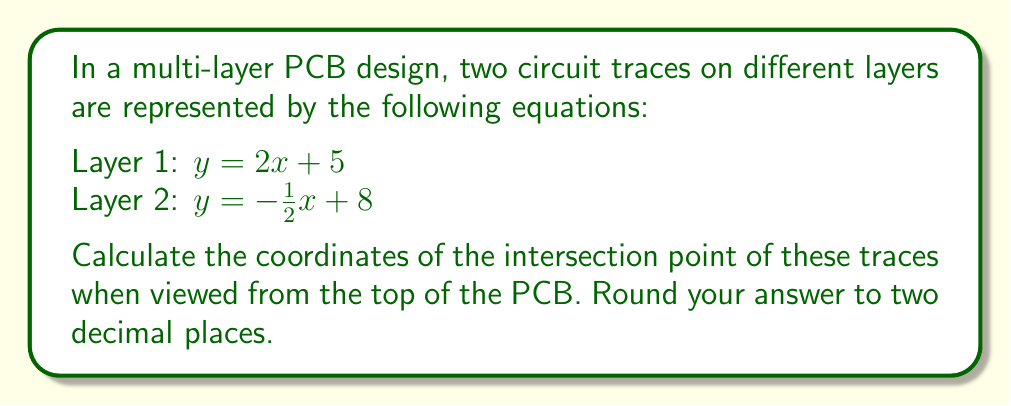Give your solution to this math problem. To find the intersection point of the two circuit traces, we need to solve the system of equations:

$$\begin{cases}
y = 2x + 5 \\
y = -\frac{1}{2}x + 8
\end{cases}$$

Step 1: Set the equations equal to each other since they represent the same y-coordinate at the intersection point.
$2x + 5 = -\frac{1}{2}x + 8$

Step 2: Solve for x by adding $\frac{1}{2}x$ to both sides and subtracting 5 from both sides.
$\frac{5}{2}x = 3$

Step 3: Divide both sides by $\frac{5}{2}$ to isolate x.
$x = \frac{3}{\frac{5}{2}} = \frac{6}{5} = 1.2$

Step 4: Substitute this x-value into either of the original equations to find y. Let's use the first equation:
$y = 2(1.2) + 5 = 2.4 + 5 = 7.4$

Step 5: Round both coordinates to two decimal places.
x = 1.20
y = 7.40

Therefore, the intersection point is (1.20, 7.40).

[asy]
unitsize(1cm);
draw((-1,0)--(5,0),arrow=Arrow(TeXHead));
draw((0,-1)--(0,10),arrow=Arrow(TeXHead));
draw((-1,3)--(4,11),red);
draw((-1,8.5)--(5,5.5),blue);
dot((1.2,7.4));
label("(1.20, 7.40)", (1.2,7.4), NE);
label("x", (5,0), E);
label("y", (0,10), N);
label("Layer 1", (3,9), E);
label("Layer 2", (3,6), E);
[/asy]
Answer: (1.20, 7.40) 